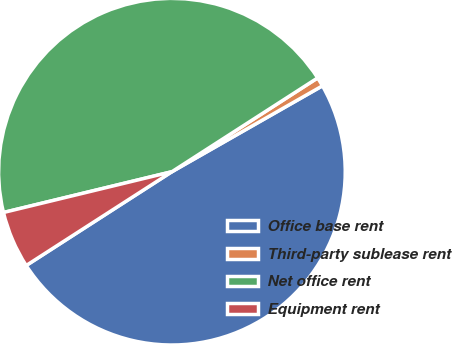Convert chart to OTSL. <chart><loc_0><loc_0><loc_500><loc_500><pie_chart><fcel>Office base rent<fcel>Third-party sublease rent<fcel>Net office rent<fcel>Equipment rent<nl><fcel>49.15%<fcel>0.85%<fcel>44.68%<fcel>5.32%<nl></chart> 